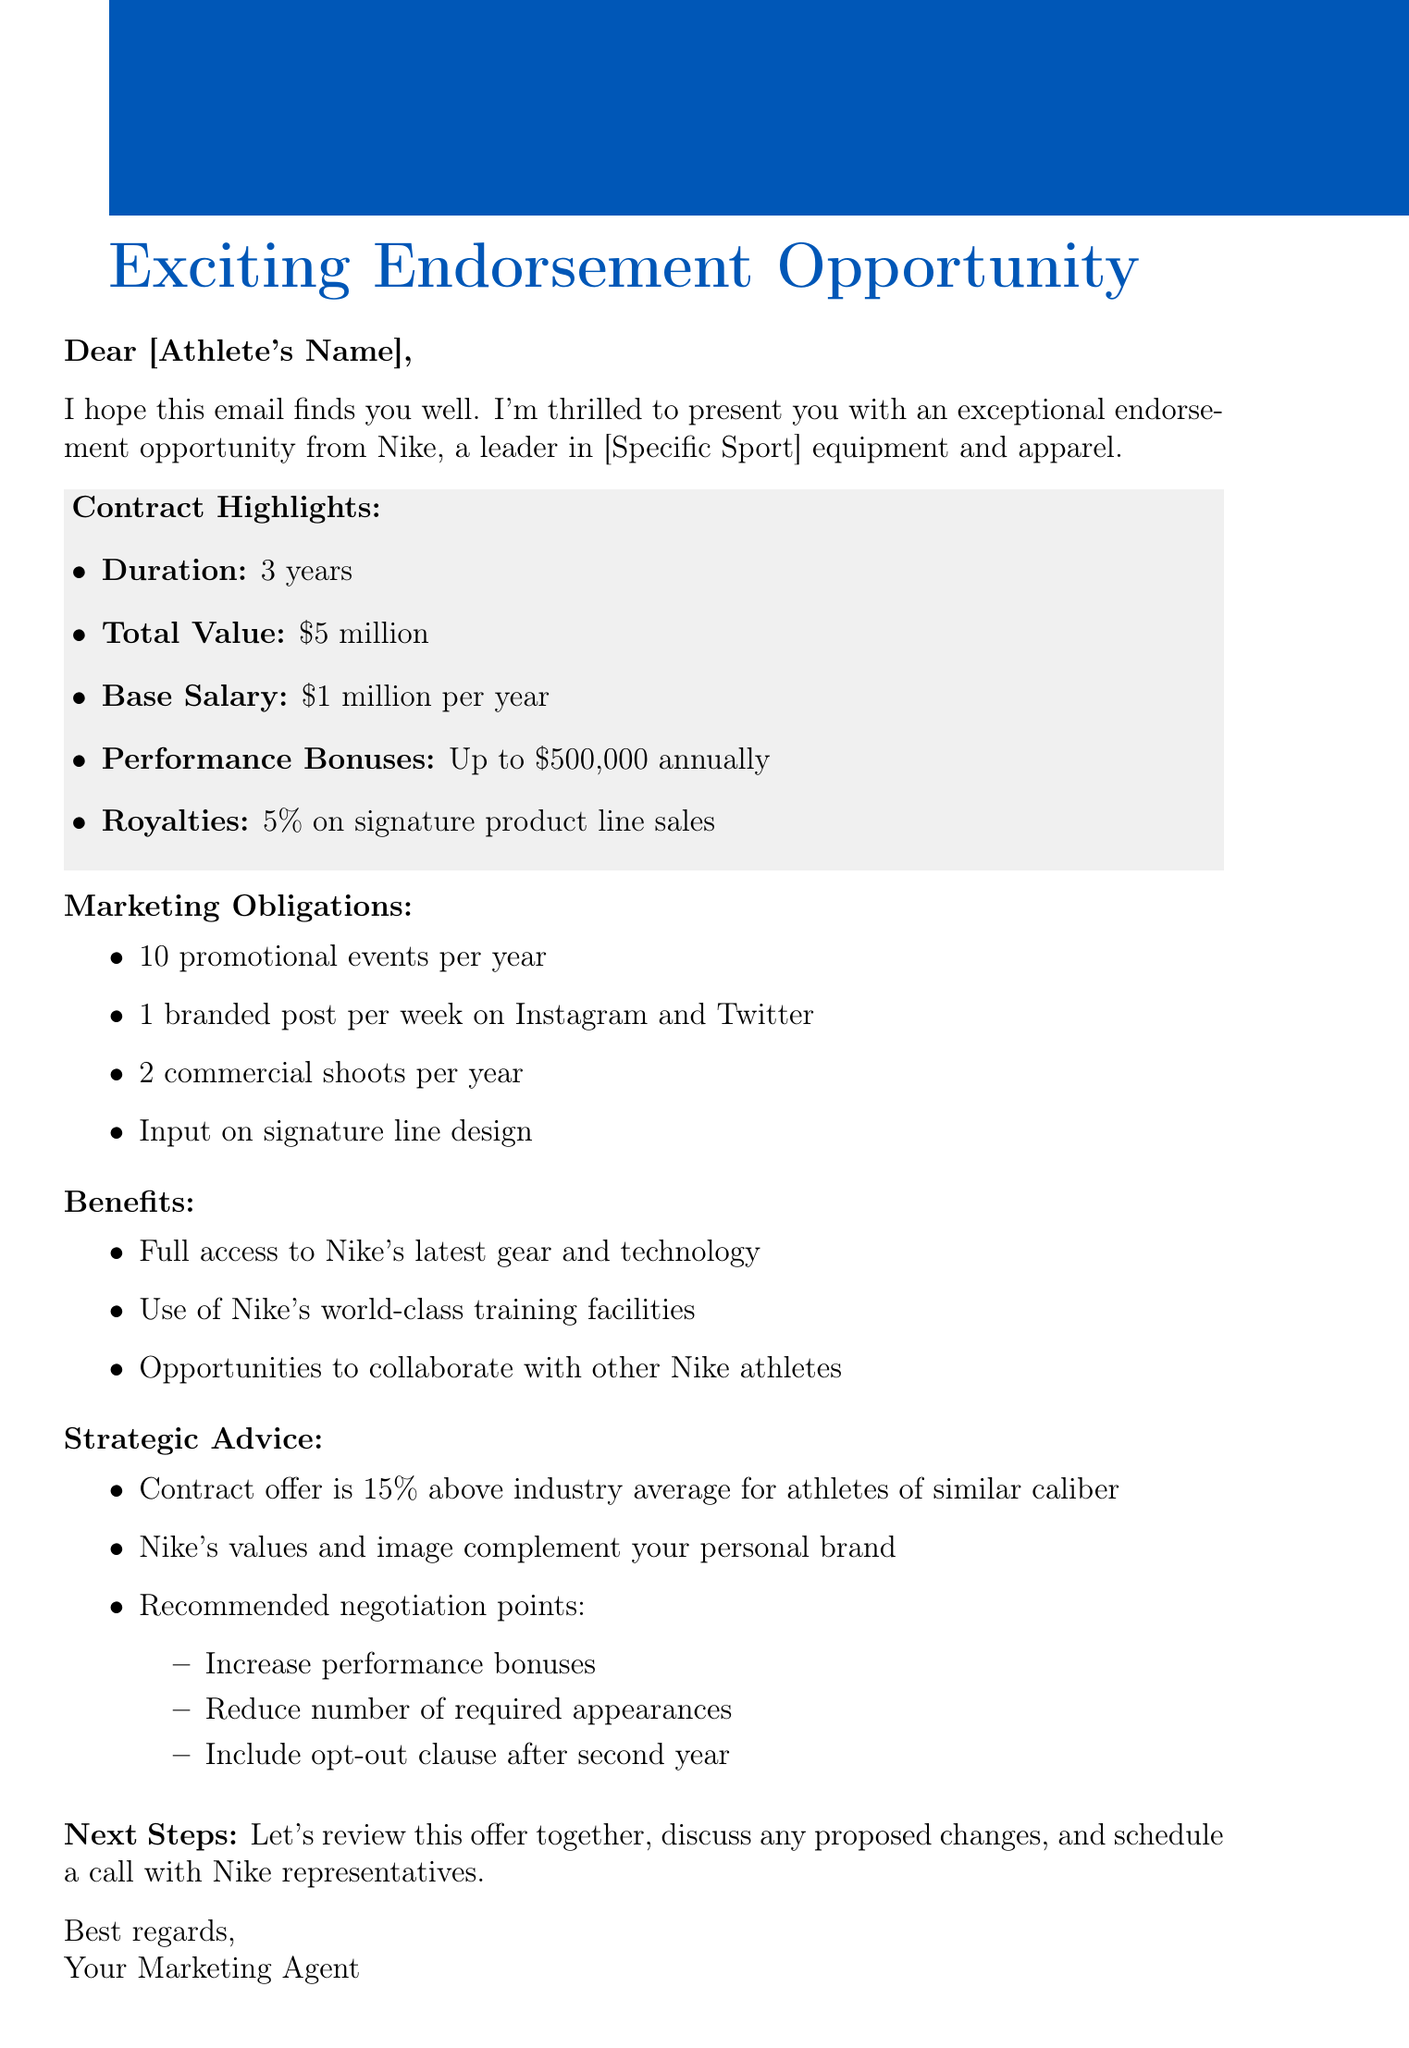What is the total contract value? The total contract value is mentioned directly in the contract details section.
Answer: $5 million How long is the contract duration? The contract duration is specified in the contract details section.
Answer: 3 years What is the base salary per year? The base salary is listed in the compensation breakdown section of the document.
Answer: $1 million per year How many promotional events are required each year? The number of promotional events is specified under marketing obligations.
Answer: 10 promotional events What percentage of royalties will the athlete receive? The royalty percentage is outlined in the compensation breakdown of the document.
Answer: 5% What is the strategic advice regarding market value? The strategic advice includes a comparison to industry average values.
Answer: Contract offer is 15% above industry average for athletes of similar caliber What is one of the recommended negotiation points? Recommended negotiation points are found in the strategic advice section.
Answer: Increase performance bonuses What kind of access will the athlete have to Nike's gear? The benefits section mentions the type of access the athlete will have.
Answer: Full access to Nike's latest gear and technology Is there an exclusivity clause in the contract? The document mentions an exclusivity clause related to brand endorsements.
Answer: Yes, no endorsement of competing brands during contract period 